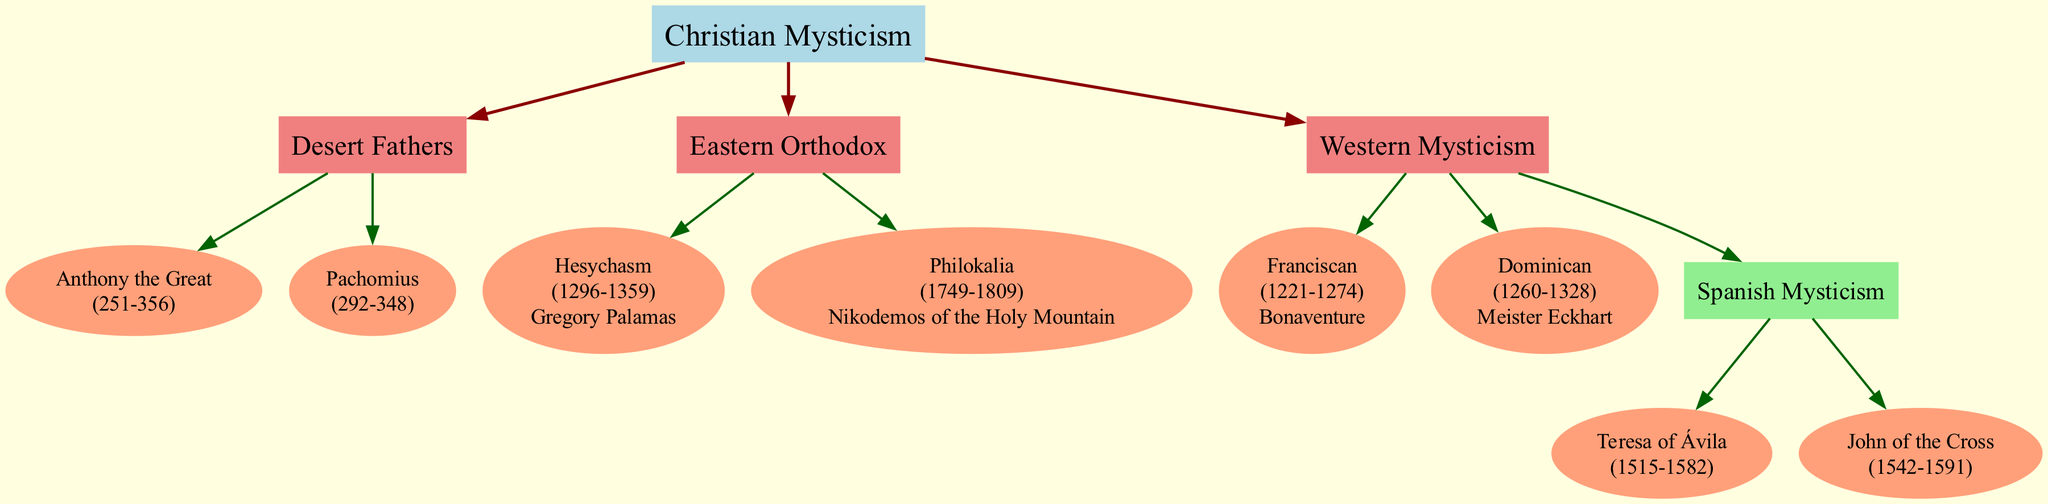What is the root of the family tree? The root node of the diagram represents the foundation of the family tree, which is labeled "Christian Mysticism." It is the starting point from which all branches and descendants stem.
Answer: Christian Mysticism How many main branches are there under Christian Mysticism? The diagram shows three main branches under the root node. Each branch is represented as a direct descendant of the root.
Answer: 3 Who is the figure associated with Hesychasm? The figure associated with the branch of Hesychasm is explicitly mentioned in the diagram. It states "Gregory Palamas" as the influential figure in this mystical tradition, and the name is directly linked to the Hesychasm node.
Answer: Gregory Palamas Which mystical figure lived the latest, according to the diagram? To determine the latest figure, I look at the years listed next to each descendant. "Nikodemos of the Holy Mountain" (1749-1809) is the descendant with the latest end year, which is the highest value year in this genealogical context.
Answer: Nikodemos of the Holy Mountain What tradition does Teresa of Ávila belong to? The diagram specifies that Teresa of Ávila is a descendant of the "Spanish Mysticism" branch, clearly indicating her affiliation with this specific mystical tradition within Western Mysticism.
Answer: Spanish Mysticism True or False: Pachomius is a descendant of the Desert Fathers. The diagram establishes that Pachomius is a direct descendant (node) under the "Desert Fathers" branch, confirming that he belongs to this lineage of mystical traditions.
Answer: True How many figures are associated with the Spanish Mysticism branch? The diagram indicates that there are two figures explicitly mentioned under the "Spanish Mysticism" branch — Teresa of Ávila and John of the Cross — showing that this branch consists of multiple influential figures.
Answer: 2 Which branch is linked directly to the year range 1221-1328? To find which branch has a figure with the year range 1221-1328, I look for the figure "Meister Eckhart," who is associated with the "Dominican" branch. This branch connects directly to that specific timeframe.
Answer: Dominican Which two figures are from the Western Mysticism tradition? The diagram lists Bonaventure and Meister Eckhart as figures within the "Western Mysticism" branch, confirming their roles and significant presence in this particular tradition.
Answer: Bonaventure, Meister Eckhart 